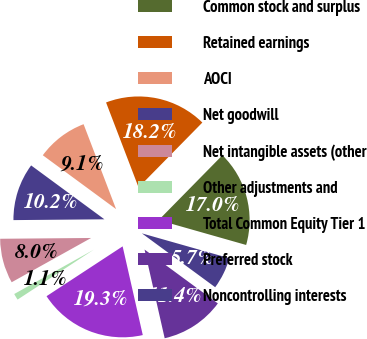<chart> <loc_0><loc_0><loc_500><loc_500><pie_chart><fcel>Common stock and surplus<fcel>Retained earnings<fcel>AOCI<fcel>Net goodwill<fcel>Net intangible assets (other<fcel>Other adjustments and<fcel>Total Common Equity Tier 1<fcel>Preferred stock<fcel>Noncontrolling interests<nl><fcel>17.04%<fcel>18.18%<fcel>9.09%<fcel>10.23%<fcel>7.95%<fcel>1.14%<fcel>19.32%<fcel>11.36%<fcel>5.68%<nl></chart> 